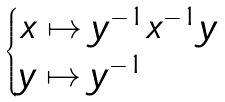<formula> <loc_0><loc_0><loc_500><loc_500>\begin{cases} x \mapsto y ^ { - 1 } x ^ { - 1 } y \\ y \mapsto y ^ { - 1 } \end{cases}</formula> 